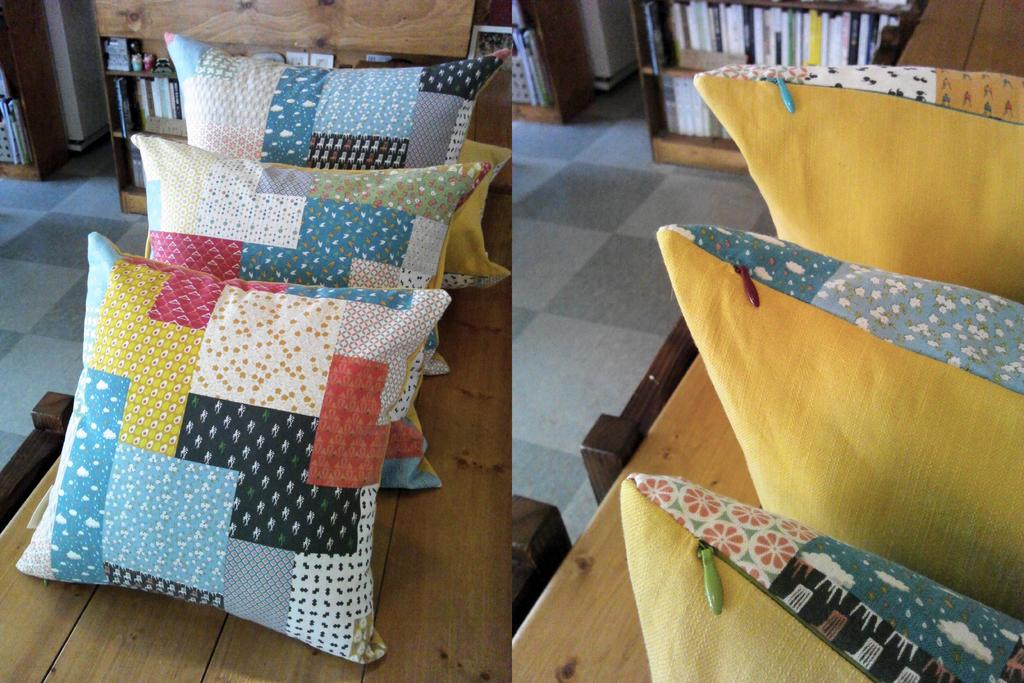What objects are on the tables in the image? There are cushions on tables in the image. What can be seen in the background of the image? There are books in racks in the background of the image. How does the car transport the partner in the image? There is no car or partner present in the image; it only features cushions on tables and books in racks. 